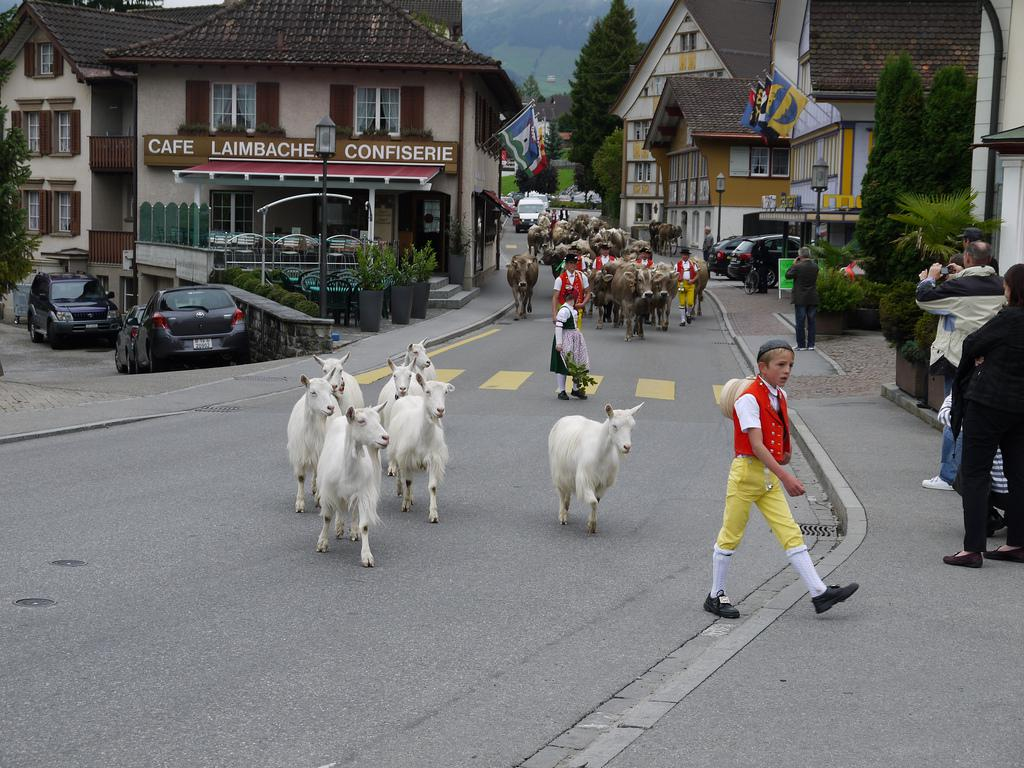Question: what is following the boy?
Choices:
A. Dogs.
B. Cows.
C. Goats.
D. Sheep.
Answer with the letter. Answer: C Question: what kind of building is marked "confiserie"?
Choices:
A. A candy factory.
B. A cafe.
C. A bakery.
D. A cookie store.
Answer with the letter. Answer: B Question: who is standing near the crosswalk?
Choices:
A. A boy.
B. A girl.
C. A grandmother.
D. A crossing guard.
Answer with the letter. Answer: B Question: what is hanging off the buildings?
Choices:
A. Banners.
B. Streamers.
C. Flags.
D. Scaffolding.
Answer with the letter. Answer: C Question: what color are the lines on the street?
Choices:
A. Yellow.
B. White.
C. Red.
D. Green.
Answer with the letter. Answer: A Question: what is in the parade?
Choices:
A. Animals.
B. Bands.
C. Floats.
D. Fire engine.
Answer with the letter. Answer: A Question: where was the photo taken?
Choices:
A. On the strip.
B. On the highway.
C. On a city street.
D. By the mall.
Answer with the letter. Answer: C Question: where is the cafe located?
Choices:
A. Around the corner.
B. Next to the supermarket.
C. On the next road.
D. In the back.
Answer with the letter. Answer: D Question: what color are the pants of the boy?
Choices:
A. Black.
B. Yellow.
C. White.
D. Green.
Answer with the letter. Answer: B Question: what is the person in black doing?
Choices:
A. Standing and watching.
B. Looking at a dog.
C. Browsing the internet.
D. Making a paper airplane.
Answer with the letter. Answer: A Question: what is the boy wearing?
Choices:
A. Blue jeans and a denim jacket.
B. A superman costume.
C. Yellow pants and a red vest.
D. Tattered pants and a dirty shirt.
Answer with the letter. Answer: C Question: what type of animals are in the background?
Choices:
A. A flock of geese.
B. A pack of feral cats.
C. A herd of cows.
D. A crouching tiger.
Answer with the letter. Answer: C Question: what is the boy wearing on his head?
Choices:
A. A small black cap.
B. Sunglasses.
C. A go-pro camera.
D. A khaki bucket hat.
Answer with the letter. Answer: A Question: what kind of animal is crossing the road?
Choices:
A. Lamb.
B. Goat.
C. Llama.
D. Sheep.
Answer with the letter. Answer: D Question: how many animals are following the boy?
Choices:
A. 6.
B. 7.
C. 5.
D. 4.
Answer with the letter. Answer: B 